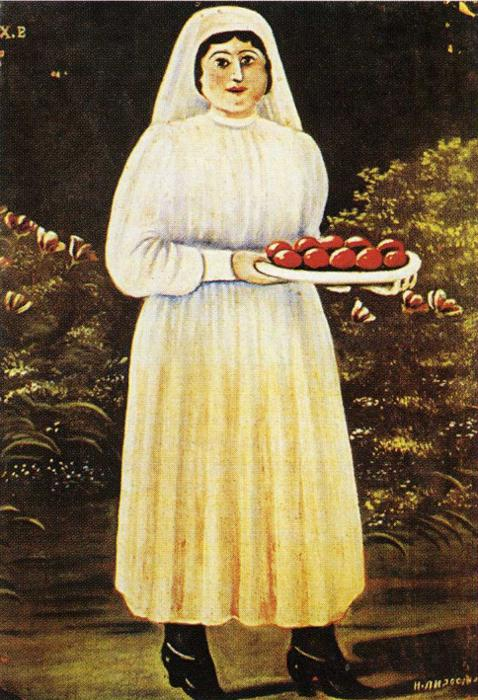What would you ask this woman if you met her? If I could speak to this woman, I’d ask her about the significance of the apples she holds. Do they represent a successful harvest, a special occasion, or perhaps a cherished tradition? I’d also like to know more about her life in the village, the stories behind her serene expression, and the experiences that shaped her connections to the land and its yearly cycles of growth and abundance. 